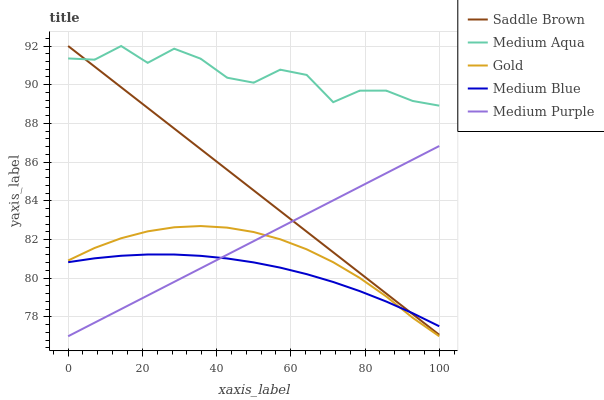Does Medium Blue have the minimum area under the curve?
Answer yes or no. Yes. Does Medium Aqua have the maximum area under the curve?
Answer yes or no. Yes. Does Medium Aqua have the minimum area under the curve?
Answer yes or no. No. Does Medium Blue have the maximum area under the curve?
Answer yes or no. No. Is Saddle Brown the smoothest?
Answer yes or no. Yes. Is Medium Aqua the roughest?
Answer yes or no. Yes. Is Medium Blue the smoothest?
Answer yes or no. No. Is Medium Blue the roughest?
Answer yes or no. No. Does Medium Purple have the lowest value?
Answer yes or no. Yes. Does Medium Blue have the lowest value?
Answer yes or no. No. Does Saddle Brown have the highest value?
Answer yes or no. Yes. Does Medium Blue have the highest value?
Answer yes or no. No. Is Gold less than Saddle Brown?
Answer yes or no. Yes. Is Medium Aqua greater than Medium Purple?
Answer yes or no. Yes. Does Gold intersect Medium Purple?
Answer yes or no. Yes. Is Gold less than Medium Purple?
Answer yes or no. No. Is Gold greater than Medium Purple?
Answer yes or no. No. Does Gold intersect Saddle Brown?
Answer yes or no. No. 